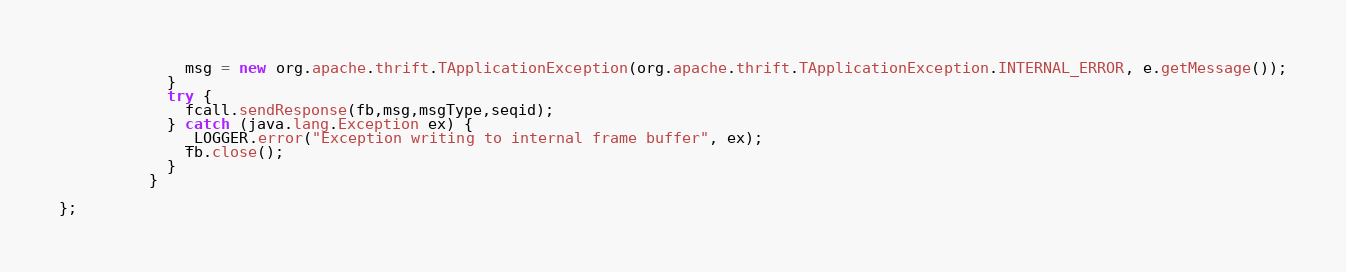Convert code to text. <code><loc_0><loc_0><loc_500><loc_500><_Java_>              msg = new org.apache.thrift.TApplicationException(org.apache.thrift.TApplicationException.INTERNAL_ERROR, e.getMessage());
            }
            try {
              fcall.sendResponse(fb,msg,msgType,seqid);
            } catch (java.lang.Exception ex) {
              _LOGGER.error("Exception writing to internal frame buffer", ex);
              fb.close();
            }
          }

};</code> 